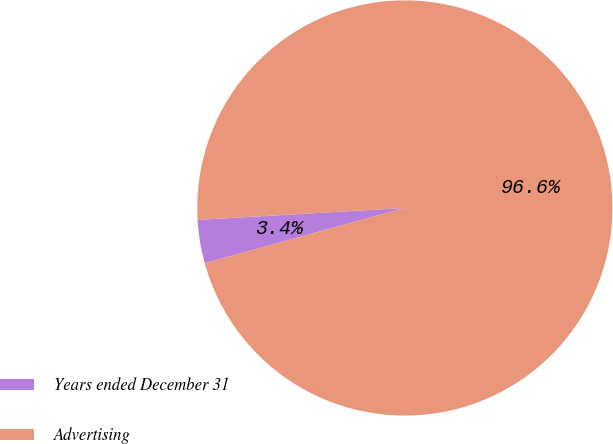<chart> <loc_0><loc_0><loc_500><loc_500><pie_chart><fcel>Years ended December 31<fcel>Advertising<nl><fcel>3.37%<fcel>96.63%<nl></chart> 